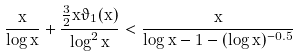Convert formula to latex. <formula><loc_0><loc_0><loc_500><loc_500>\frac { x } { \log x } + \frac { \frac { 3 } { 2 } x \vartheta _ { 1 } ( x ) } { \log ^ { 2 } x } < \frac { x } { \log x - 1 - ( \log x ) ^ { - 0 . 5 } }</formula> 